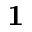Convert formula to latex. <formula><loc_0><loc_0><loc_500><loc_500>1</formula> 